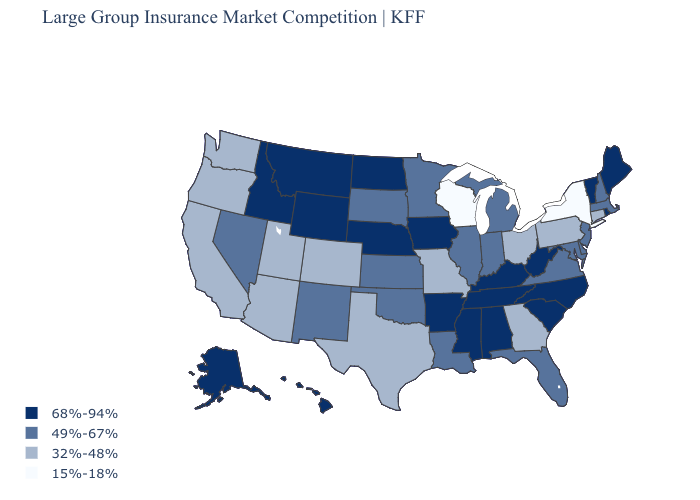What is the value of Kentucky?
Answer briefly. 68%-94%. How many symbols are there in the legend?
Give a very brief answer. 4. Among the states that border Kansas , does Nebraska have the lowest value?
Short answer required. No. What is the value of New Hampshire?
Short answer required. 49%-67%. Which states have the lowest value in the USA?
Write a very short answer. New York, Wisconsin. What is the lowest value in the West?
Answer briefly. 32%-48%. What is the value of New Mexico?
Short answer required. 49%-67%. Name the states that have a value in the range 32%-48%?
Write a very short answer. Arizona, California, Colorado, Connecticut, Georgia, Missouri, Ohio, Oregon, Pennsylvania, Texas, Utah, Washington. Does Vermont have the lowest value in the USA?
Keep it brief. No. Among the states that border South Carolina , which have the highest value?
Answer briefly. North Carolina. Does Delaware have the same value as Utah?
Give a very brief answer. No. Does Montana have the highest value in the West?
Keep it brief. Yes. Does Colorado have the highest value in the West?
Keep it brief. No. Does Utah have a lower value than Wisconsin?
Answer briefly. No. What is the value of Indiana?
Short answer required. 49%-67%. 